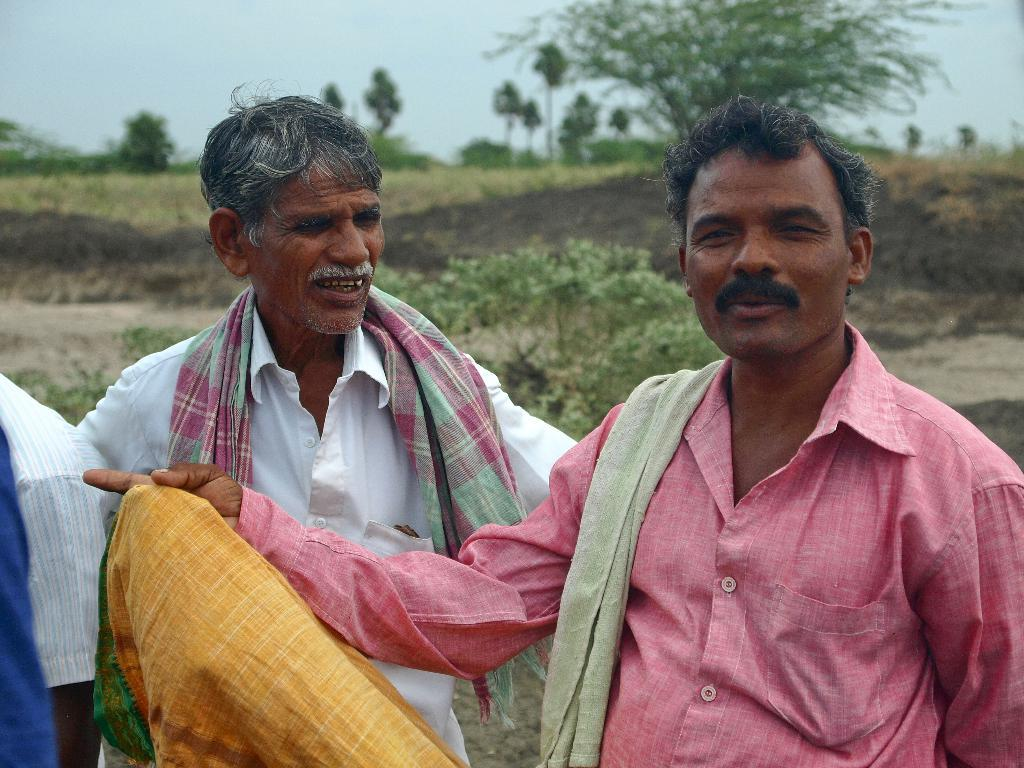How many men are in the image? There are three men in the image. What are the men wearing or carrying on their shoulders? The men have towels on their shoulders. What position are the men in? The men are standing. What type of vegetation can be seen in the image? There are plants and trees in the image. What part of the natural environment is visible in the image? The sky is visible in the image. What type of drug can be seen in the image? There is no drug present in the image; it features three men with towels on their shoulders, standing, and surrounded by plants, trees, and the sky. 